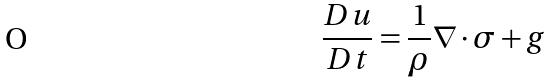Convert formula to latex. <formula><loc_0><loc_0><loc_500><loc_500>\frac { D u } { D t } = \frac { 1 } { \rho } \nabla \cdot \sigma + g</formula> 